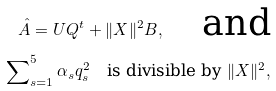Convert formula to latex. <formula><loc_0><loc_0><loc_500><loc_500>\hat { A } = U Q ^ { t } + \| X \| ^ { 2 } B , \quad \text {and} \\ \sum \nolimits _ { s = 1 } ^ { 5 } \alpha _ { s } q _ { s } ^ { 2 } \quad \text {is divisible by $\|X\|^{2}$} ,</formula> 